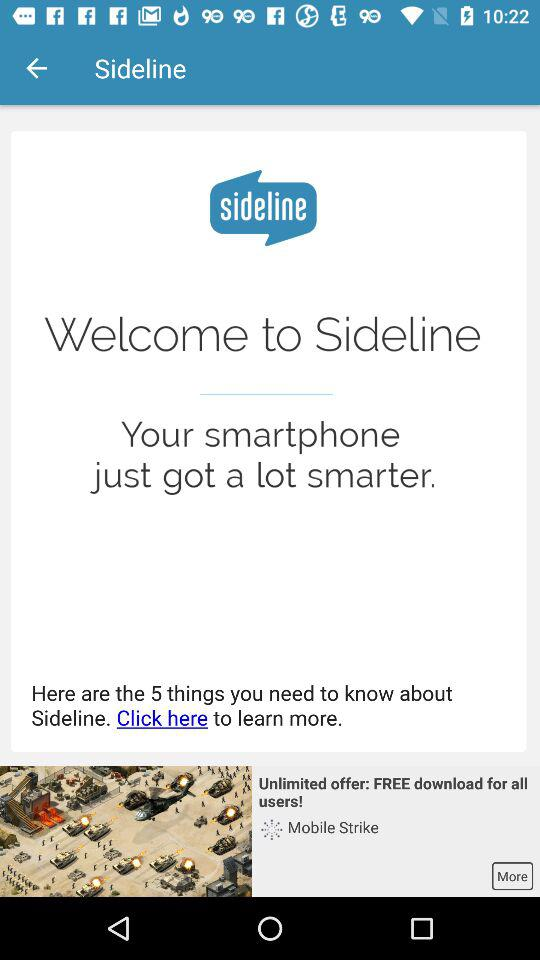What is the name of the application? The name of the application is "Sideline". 